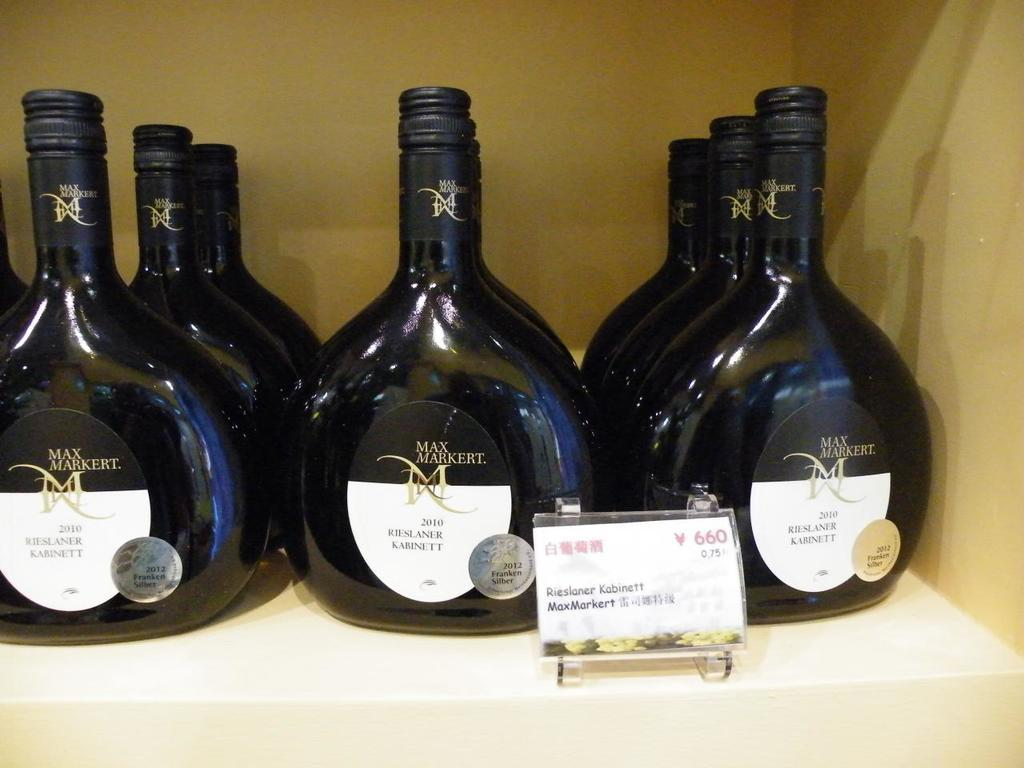<image>
Summarize the visual content of the image. Many black bottles on a shelf with a sign in front that says 660. 